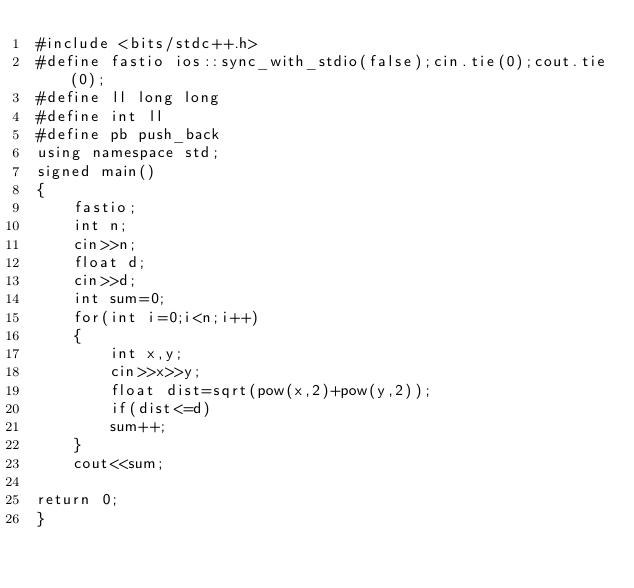<code> <loc_0><loc_0><loc_500><loc_500><_C++_>#include <bits/stdc++.h>
#define fastio ios::sync_with_stdio(false);cin.tie(0);cout.tie(0);
#define ll long long
#define int ll
#define pb push_back
using namespace std;
signed main()
{
    fastio;
    int n;
    cin>>n;
    float d;
    cin>>d;
    int sum=0;
    for(int i=0;i<n;i++)
    {
        int x,y;
        cin>>x>>y;
        float dist=sqrt(pow(x,2)+pow(y,2));
        if(dist<=d)
        sum++;
    }      
    cout<<sum;
           
return 0;
}</code> 